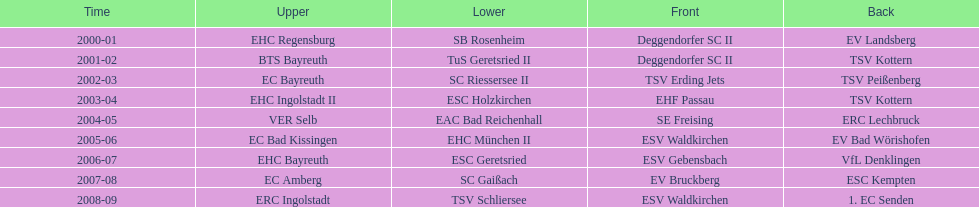What is the number of times deggendorfer sc ii is on the list? 2. 